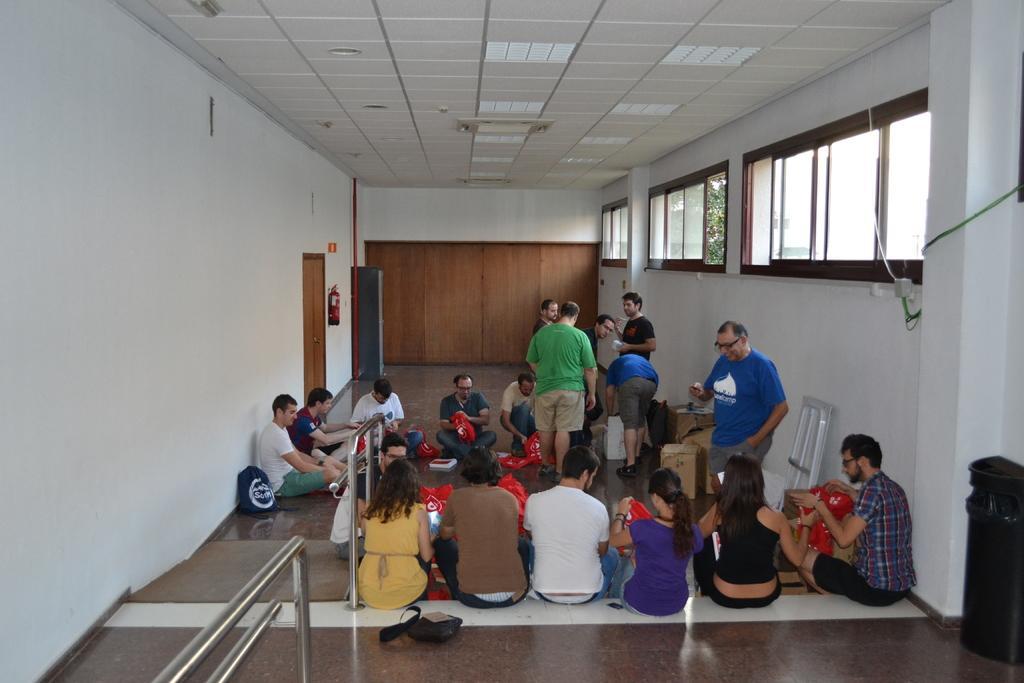Could you give a brief overview of what you see in this image? In the foreground of this image, there are people sitting on the floor and few are standing. We can also see a bag and few cardboard boxes on the floor. In the background, there is a door, wall, fire extinguisher, wooden wall, ceiling and few windows. 